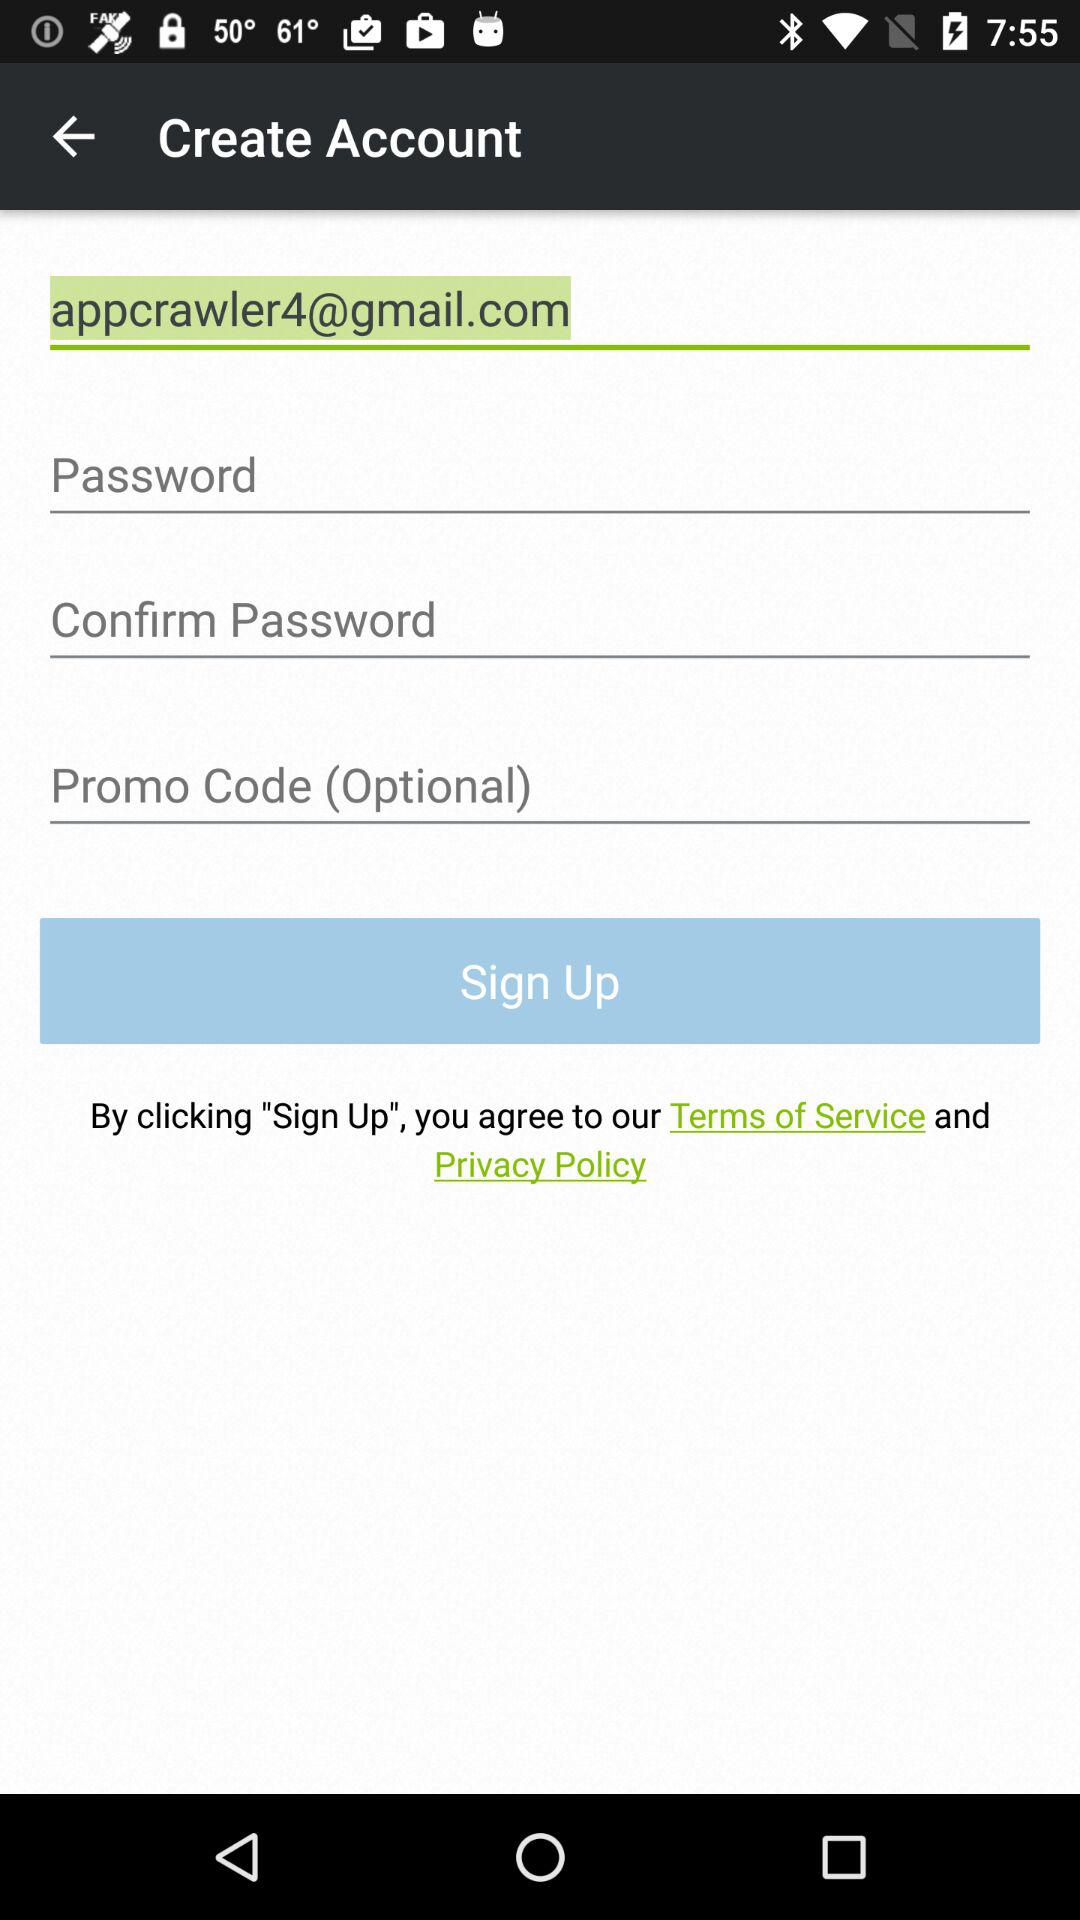What field is optional? The field "Promo Code" is optional. 